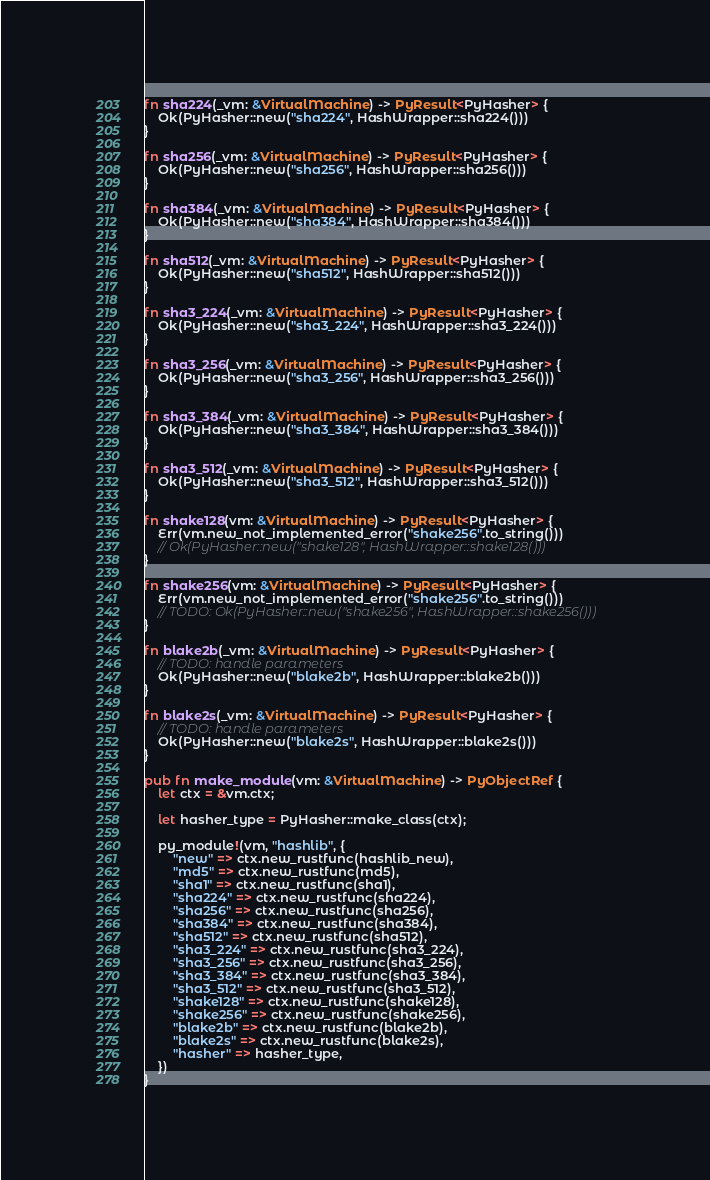<code> <loc_0><loc_0><loc_500><loc_500><_Rust_>fn sha224(_vm: &VirtualMachine) -> PyResult<PyHasher> {
    Ok(PyHasher::new("sha224", HashWrapper::sha224()))
}

fn sha256(_vm: &VirtualMachine) -> PyResult<PyHasher> {
    Ok(PyHasher::new("sha256", HashWrapper::sha256()))
}

fn sha384(_vm: &VirtualMachine) -> PyResult<PyHasher> {
    Ok(PyHasher::new("sha384", HashWrapper::sha384()))
}

fn sha512(_vm: &VirtualMachine) -> PyResult<PyHasher> {
    Ok(PyHasher::new("sha512", HashWrapper::sha512()))
}

fn sha3_224(_vm: &VirtualMachine) -> PyResult<PyHasher> {
    Ok(PyHasher::new("sha3_224", HashWrapper::sha3_224()))
}

fn sha3_256(_vm: &VirtualMachine) -> PyResult<PyHasher> {
    Ok(PyHasher::new("sha3_256", HashWrapper::sha3_256()))
}

fn sha3_384(_vm: &VirtualMachine) -> PyResult<PyHasher> {
    Ok(PyHasher::new("sha3_384", HashWrapper::sha3_384()))
}

fn sha3_512(_vm: &VirtualMachine) -> PyResult<PyHasher> {
    Ok(PyHasher::new("sha3_512", HashWrapper::sha3_512()))
}

fn shake128(vm: &VirtualMachine) -> PyResult<PyHasher> {
    Err(vm.new_not_implemented_error("shake256".to_string()))
    // Ok(PyHasher::new("shake128", HashWrapper::shake128()))
}

fn shake256(vm: &VirtualMachine) -> PyResult<PyHasher> {
    Err(vm.new_not_implemented_error("shake256".to_string()))
    // TODO: Ok(PyHasher::new("shake256", HashWrapper::shake256()))
}

fn blake2b(_vm: &VirtualMachine) -> PyResult<PyHasher> {
    // TODO: handle parameters
    Ok(PyHasher::new("blake2b", HashWrapper::blake2b()))
}

fn blake2s(_vm: &VirtualMachine) -> PyResult<PyHasher> {
    // TODO: handle parameters
    Ok(PyHasher::new("blake2s", HashWrapper::blake2s()))
}

pub fn make_module(vm: &VirtualMachine) -> PyObjectRef {
    let ctx = &vm.ctx;

    let hasher_type = PyHasher::make_class(ctx);

    py_module!(vm, "hashlib", {
        "new" => ctx.new_rustfunc(hashlib_new),
        "md5" => ctx.new_rustfunc(md5),
        "sha1" => ctx.new_rustfunc(sha1),
        "sha224" => ctx.new_rustfunc(sha224),
        "sha256" => ctx.new_rustfunc(sha256),
        "sha384" => ctx.new_rustfunc(sha384),
        "sha512" => ctx.new_rustfunc(sha512),
        "sha3_224" => ctx.new_rustfunc(sha3_224),
        "sha3_256" => ctx.new_rustfunc(sha3_256),
        "sha3_384" => ctx.new_rustfunc(sha3_384),
        "sha3_512" => ctx.new_rustfunc(sha3_512),
        "shake128" => ctx.new_rustfunc(shake128),
        "shake256" => ctx.new_rustfunc(shake256),
        "blake2b" => ctx.new_rustfunc(blake2b),
        "blake2s" => ctx.new_rustfunc(blake2s),
        "hasher" => hasher_type,
    })
}
</code> 